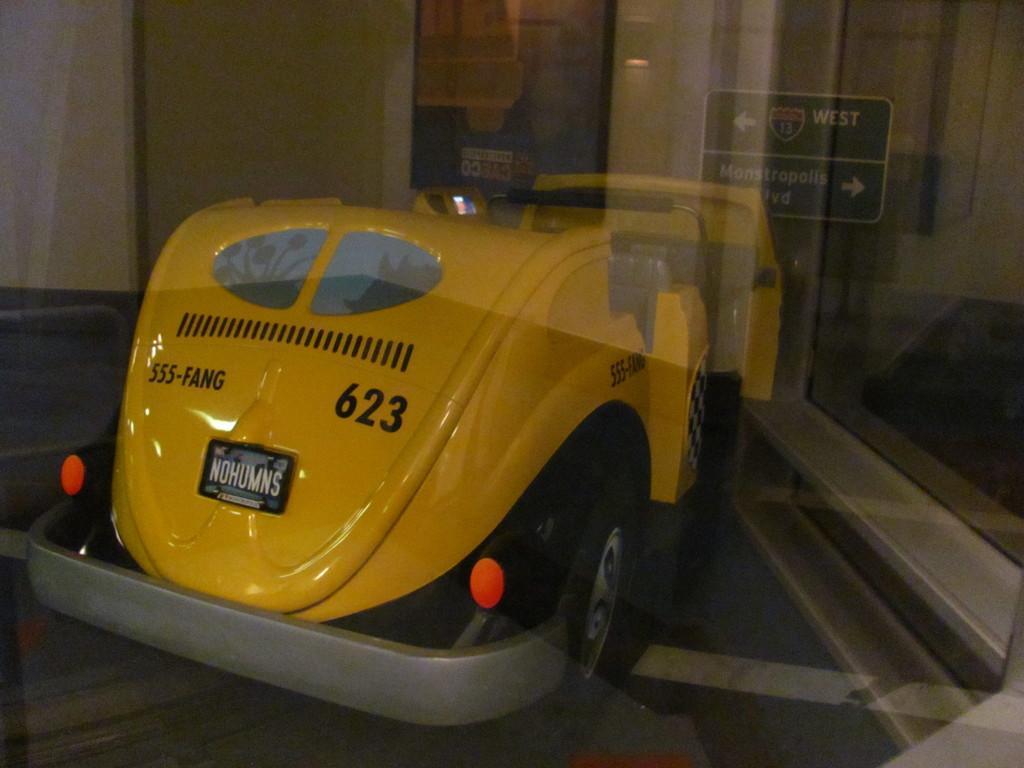Please provide a concise description of this image. In this image in front there is a toy car. In the background of the image there is a photo frame attached to the wall. On the right side of the image there is a directional board. There is a glass window. 